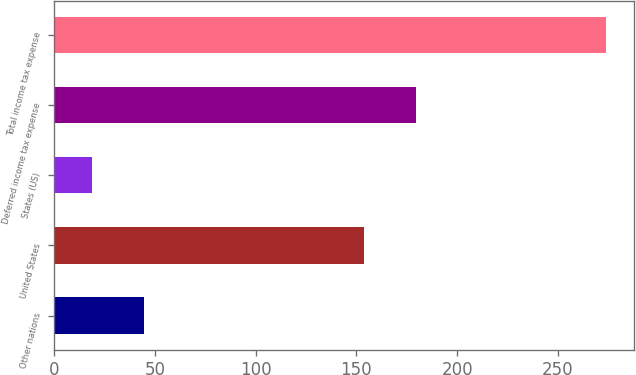Convert chart to OTSL. <chart><loc_0><loc_0><loc_500><loc_500><bar_chart><fcel>Other nations<fcel>United States<fcel>States (US)<fcel>Deferred income tax expense<fcel>Total income tax expense<nl><fcel>44.5<fcel>154<fcel>19<fcel>179.5<fcel>274<nl></chart> 